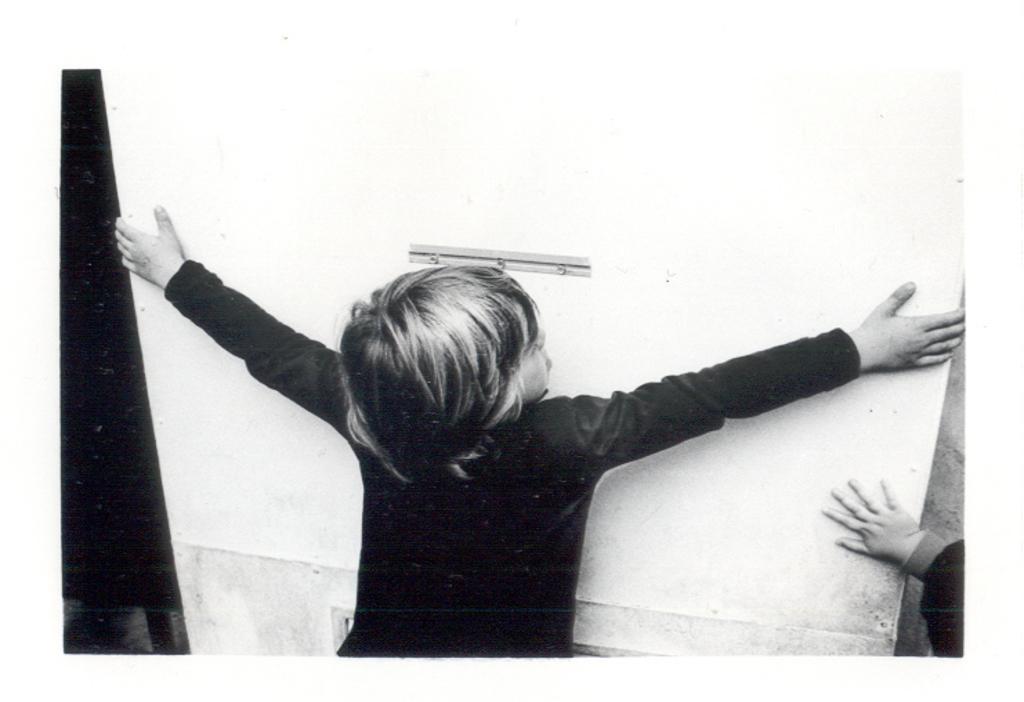In one or two sentences, can you explain what this image depicts? In this image I can see a person is holding the object and I can see the another person hand on it. The image is in black and white. 